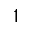<formula> <loc_0><loc_0><loc_500><loc_500>^ { 1 }</formula> 